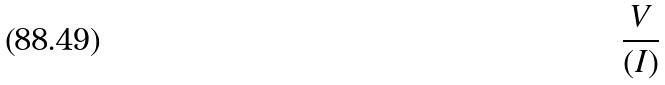Convert formula to latex. <formula><loc_0><loc_0><loc_500><loc_500>\frac { V } { ( I ) }</formula> 